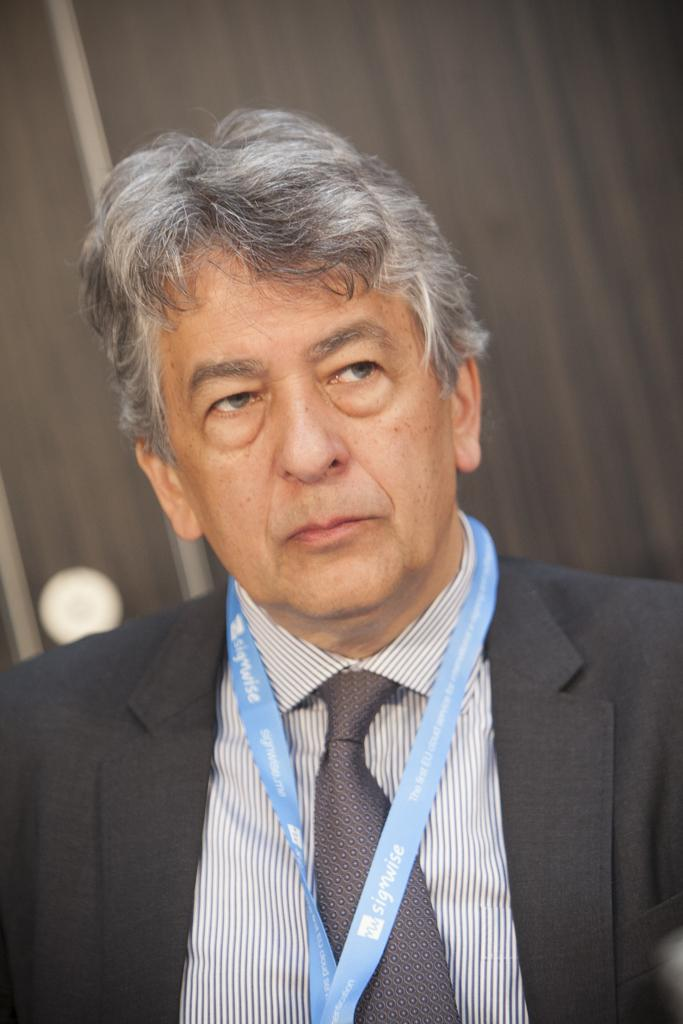Who is present in the image? There is a man in the image. What is the man wearing? The man is wearing a black suit. In which direction is the man looking? The man is looking to the right side. What can be seen in the background of the image? There is a curtain and a pole in the background of the image. Can you see the servant helping the man in the image? There is no servant present in the image, and the man is not receiving any help. 